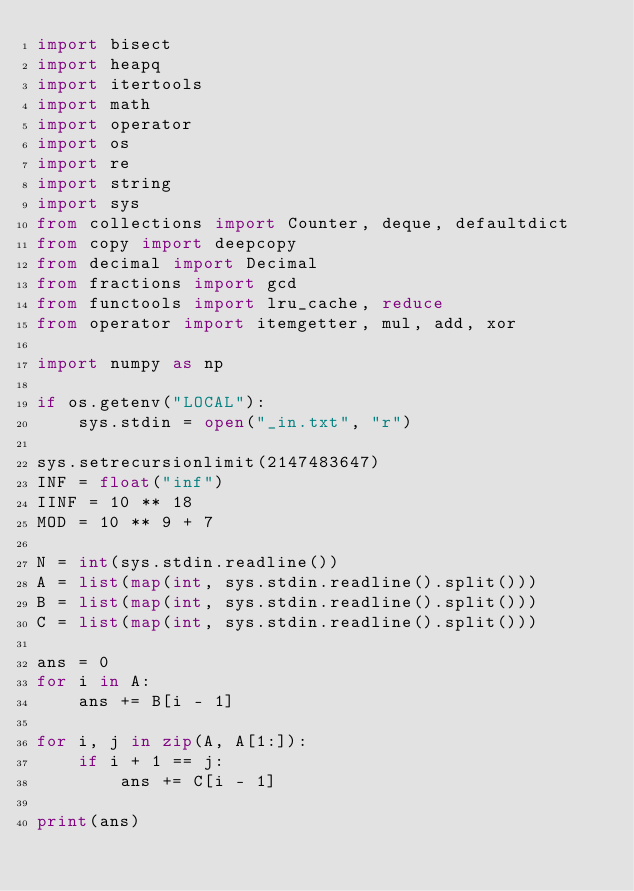Convert code to text. <code><loc_0><loc_0><loc_500><loc_500><_Python_>import bisect
import heapq
import itertools
import math
import operator
import os
import re
import string
import sys
from collections import Counter, deque, defaultdict
from copy import deepcopy
from decimal import Decimal
from fractions import gcd
from functools import lru_cache, reduce
from operator import itemgetter, mul, add, xor

import numpy as np

if os.getenv("LOCAL"):
    sys.stdin = open("_in.txt", "r")

sys.setrecursionlimit(2147483647)
INF = float("inf")
IINF = 10 ** 18
MOD = 10 ** 9 + 7

N = int(sys.stdin.readline())
A = list(map(int, sys.stdin.readline().split()))
B = list(map(int, sys.stdin.readline().split()))
C = list(map(int, sys.stdin.readline().split()))

ans = 0
for i in A:
    ans += B[i - 1]

for i, j in zip(A, A[1:]):
    if i + 1 == j:
        ans += C[i - 1]

print(ans)
</code> 